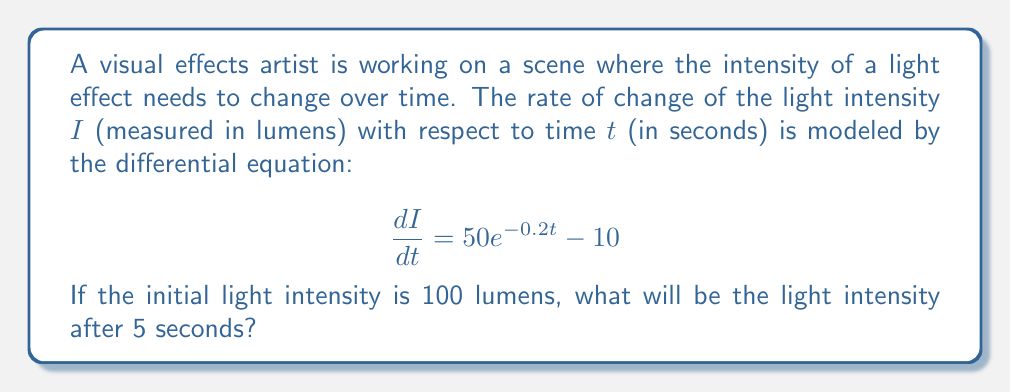Could you help me with this problem? To solve this problem, we need to follow these steps:

1) First, we need to solve the differential equation. The general form of the solution is:

   $$I = \int (50e^{-0.2t} - 10) dt + C$$

2) Let's solve the integral:
   
   $$I = -250e^{-0.2t} - 10t + C$$

3) Now we need to find the value of C using the initial condition. At t = 0, I = 100:

   $$100 = -250e^{-0.2(0)} - 10(0) + C$$
   $$100 = -250 + C$$
   $$C = 350$$

4) So, the particular solution is:

   $$I = -250e^{-0.2t} - 10t + 350$$

5) To find the intensity after 5 seconds, we substitute t = 5:

   $$I(5) = -250e^{-0.2(5)} - 10(5) + 350$$
   $$= -250e^{-1} - 50 + 350$$
   $$\approx -92.0 - 50 + 350$$
   $$= 208.0$$

Therefore, after 5 seconds, the light intensity will be approximately 208.0 lumens.
Answer: The light intensity after 5 seconds will be approximately 208.0 lumens. 